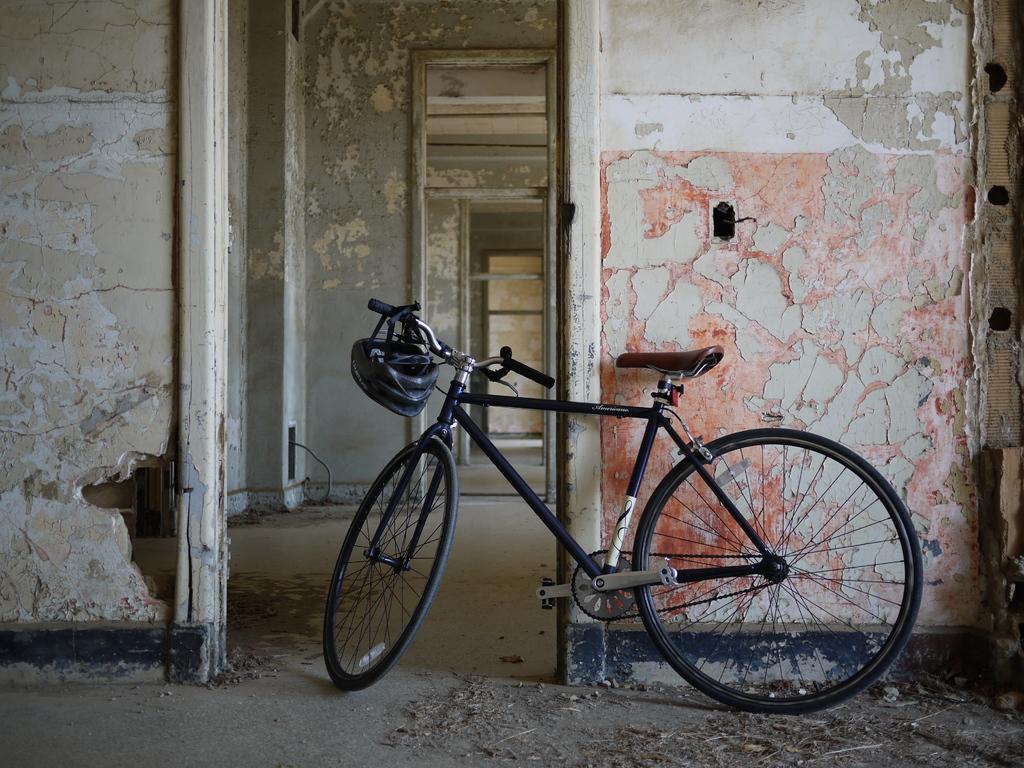Describe this image in one or two sentences. In this image there is a bicycle, beside the bicycle there is a wall for that wall there is an entrance, in the background there are walls for that walls there are entrances. 